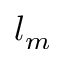<formula> <loc_0><loc_0><loc_500><loc_500>l _ { m }</formula> 